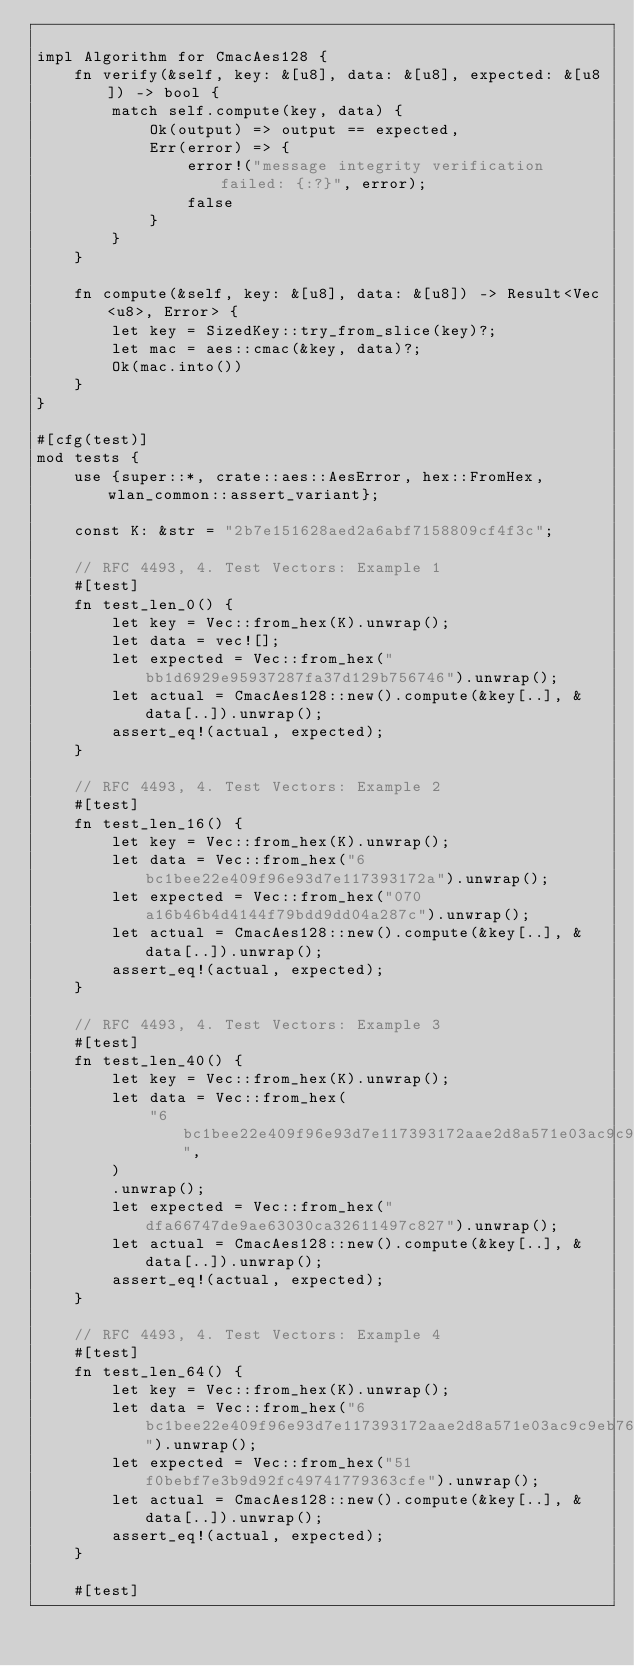<code> <loc_0><loc_0><loc_500><loc_500><_Rust_>
impl Algorithm for CmacAes128 {
    fn verify(&self, key: &[u8], data: &[u8], expected: &[u8]) -> bool {
        match self.compute(key, data) {
            Ok(output) => output == expected,
            Err(error) => {
                error!("message integrity verification failed: {:?}", error);
                false
            }
        }
    }

    fn compute(&self, key: &[u8], data: &[u8]) -> Result<Vec<u8>, Error> {
        let key = SizedKey::try_from_slice(key)?;
        let mac = aes::cmac(&key, data)?;
        Ok(mac.into())
    }
}

#[cfg(test)]
mod tests {
    use {super::*, crate::aes::AesError, hex::FromHex, wlan_common::assert_variant};

    const K: &str = "2b7e151628aed2a6abf7158809cf4f3c";

    // RFC 4493, 4. Test Vectors: Example 1
    #[test]
    fn test_len_0() {
        let key = Vec::from_hex(K).unwrap();
        let data = vec![];
        let expected = Vec::from_hex("bb1d6929e95937287fa37d129b756746").unwrap();
        let actual = CmacAes128::new().compute(&key[..], &data[..]).unwrap();
        assert_eq!(actual, expected);
    }

    // RFC 4493, 4. Test Vectors: Example 2
    #[test]
    fn test_len_16() {
        let key = Vec::from_hex(K).unwrap();
        let data = Vec::from_hex("6bc1bee22e409f96e93d7e117393172a").unwrap();
        let expected = Vec::from_hex("070a16b46b4d4144f79bdd9dd04a287c").unwrap();
        let actual = CmacAes128::new().compute(&key[..], &data[..]).unwrap();
        assert_eq!(actual, expected);
    }

    // RFC 4493, 4. Test Vectors: Example 3
    #[test]
    fn test_len_40() {
        let key = Vec::from_hex(K).unwrap();
        let data = Vec::from_hex(
            "6bc1bee22e409f96e93d7e117393172aae2d8a571e03ac9c9eb76fac45af8e5130c81c46a35ce411",
        )
        .unwrap();
        let expected = Vec::from_hex("dfa66747de9ae63030ca32611497c827").unwrap();
        let actual = CmacAes128::new().compute(&key[..], &data[..]).unwrap();
        assert_eq!(actual, expected);
    }

    // RFC 4493, 4. Test Vectors: Example 4
    #[test]
    fn test_len_64() {
        let key = Vec::from_hex(K).unwrap();
        let data = Vec::from_hex("6bc1bee22e409f96e93d7e117393172aae2d8a571e03ac9c9eb76fac45af8e5130c81c46a35ce411e5fbc1191a0a52eff69f2445df4f9b17ad2b417be66c3710").unwrap();
        let expected = Vec::from_hex("51f0bebf7e3b9d92fc49741779363cfe").unwrap();
        let actual = CmacAes128::new().compute(&key[..], &data[..]).unwrap();
        assert_eq!(actual, expected);
    }

    #[test]</code> 